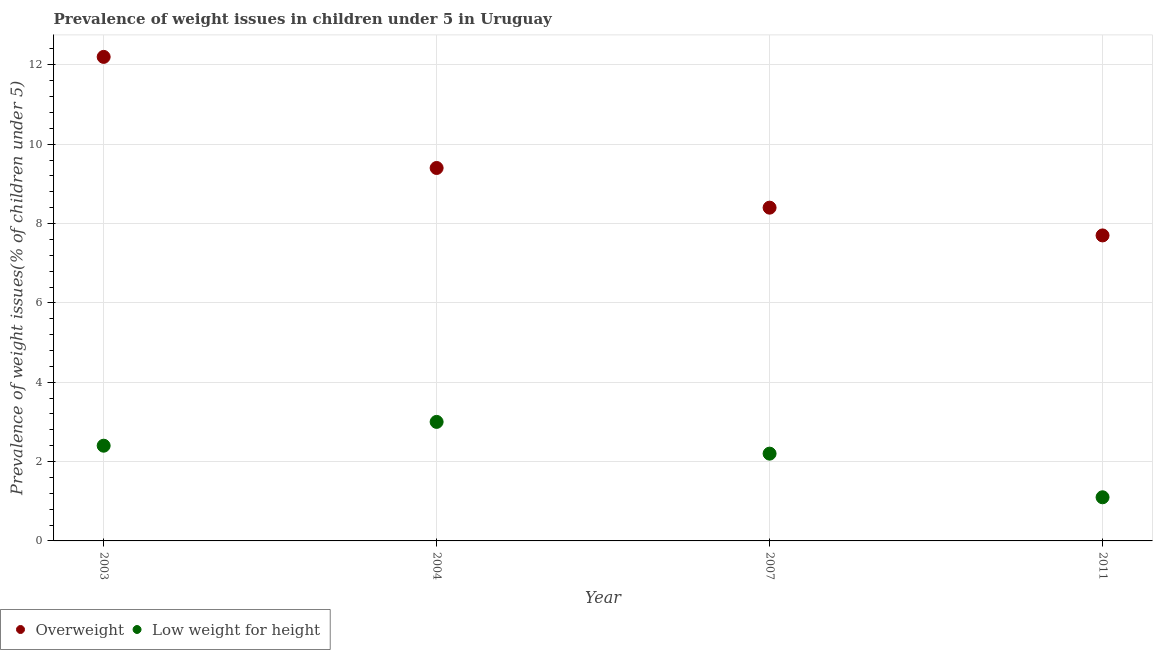How many different coloured dotlines are there?
Your answer should be compact. 2. What is the percentage of overweight children in 2003?
Give a very brief answer. 12.2. Across all years, what is the maximum percentage of overweight children?
Keep it short and to the point. 12.2. Across all years, what is the minimum percentage of overweight children?
Offer a very short reply. 7.7. In which year was the percentage of overweight children maximum?
Keep it short and to the point. 2003. What is the total percentage of overweight children in the graph?
Your response must be concise. 37.7. What is the difference between the percentage of underweight children in 2003 and that in 2007?
Your answer should be very brief. 0.2. What is the difference between the percentage of underweight children in 2011 and the percentage of overweight children in 2003?
Provide a succinct answer. -11.1. What is the average percentage of overweight children per year?
Your answer should be compact. 9.42. In the year 2011, what is the difference between the percentage of underweight children and percentage of overweight children?
Offer a very short reply. -6.6. In how many years, is the percentage of underweight children greater than 4.4 %?
Make the answer very short. 0. What is the ratio of the percentage of overweight children in 2003 to that in 2004?
Make the answer very short. 1.3. Is the percentage of overweight children in 2003 less than that in 2007?
Ensure brevity in your answer.  No. Is the difference between the percentage of underweight children in 2004 and 2011 greater than the difference between the percentage of overweight children in 2004 and 2011?
Keep it short and to the point. Yes. What is the difference between the highest and the second highest percentage of overweight children?
Your answer should be very brief. 2.8. What is the difference between the highest and the lowest percentage of overweight children?
Make the answer very short. 4.5. In how many years, is the percentage of underweight children greater than the average percentage of underweight children taken over all years?
Give a very brief answer. 3. How many years are there in the graph?
Keep it short and to the point. 4. Are the values on the major ticks of Y-axis written in scientific E-notation?
Your answer should be very brief. No. Does the graph contain any zero values?
Give a very brief answer. No. Does the graph contain grids?
Your answer should be very brief. Yes. How are the legend labels stacked?
Provide a short and direct response. Horizontal. What is the title of the graph?
Ensure brevity in your answer.  Prevalence of weight issues in children under 5 in Uruguay. Does "Researchers" appear as one of the legend labels in the graph?
Your answer should be very brief. No. What is the label or title of the X-axis?
Offer a terse response. Year. What is the label or title of the Y-axis?
Give a very brief answer. Prevalence of weight issues(% of children under 5). What is the Prevalence of weight issues(% of children under 5) of Overweight in 2003?
Keep it short and to the point. 12.2. What is the Prevalence of weight issues(% of children under 5) in Low weight for height in 2003?
Your answer should be very brief. 2.4. What is the Prevalence of weight issues(% of children under 5) in Overweight in 2004?
Your answer should be very brief. 9.4. What is the Prevalence of weight issues(% of children under 5) in Low weight for height in 2004?
Offer a very short reply. 3. What is the Prevalence of weight issues(% of children under 5) in Overweight in 2007?
Provide a short and direct response. 8.4. What is the Prevalence of weight issues(% of children under 5) of Low weight for height in 2007?
Give a very brief answer. 2.2. What is the Prevalence of weight issues(% of children under 5) in Overweight in 2011?
Your answer should be very brief. 7.7. What is the Prevalence of weight issues(% of children under 5) of Low weight for height in 2011?
Give a very brief answer. 1.1. Across all years, what is the maximum Prevalence of weight issues(% of children under 5) in Overweight?
Your answer should be compact. 12.2. Across all years, what is the maximum Prevalence of weight issues(% of children under 5) in Low weight for height?
Provide a short and direct response. 3. Across all years, what is the minimum Prevalence of weight issues(% of children under 5) in Overweight?
Keep it short and to the point. 7.7. Across all years, what is the minimum Prevalence of weight issues(% of children under 5) of Low weight for height?
Ensure brevity in your answer.  1.1. What is the total Prevalence of weight issues(% of children under 5) of Overweight in the graph?
Offer a terse response. 37.7. What is the total Prevalence of weight issues(% of children under 5) of Low weight for height in the graph?
Offer a very short reply. 8.7. What is the difference between the Prevalence of weight issues(% of children under 5) in Low weight for height in 2004 and that in 2007?
Offer a terse response. 0.8. What is the difference between the Prevalence of weight issues(% of children under 5) of Overweight in 2004 and that in 2011?
Make the answer very short. 1.7. What is the difference between the Prevalence of weight issues(% of children under 5) in Low weight for height in 2004 and that in 2011?
Your response must be concise. 1.9. What is the difference between the Prevalence of weight issues(% of children under 5) of Overweight in 2007 and that in 2011?
Provide a short and direct response. 0.7. What is the difference between the Prevalence of weight issues(% of children under 5) in Overweight in 2003 and the Prevalence of weight issues(% of children under 5) in Low weight for height in 2011?
Your answer should be very brief. 11.1. What is the difference between the Prevalence of weight issues(% of children under 5) of Overweight in 2004 and the Prevalence of weight issues(% of children under 5) of Low weight for height in 2007?
Offer a terse response. 7.2. What is the average Prevalence of weight issues(% of children under 5) in Overweight per year?
Offer a very short reply. 9.43. What is the average Prevalence of weight issues(% of children under 5) of Low weight for height per year?
Ensure brevity in your answer.  2.17. In the year 2003, what is the difference between the Prevalence of weight issues(% of children under 5) of Overweight and Prevalence of weight issues(% of children under 5) of Low weight for height?
Offer a terse response. 9.8. In the year 2007, what is the difference between the Prevalence of weight issues(% of children under 5) of Overweight and Prevalence of weight issues(% of children under 5) of Low weight for height?
Offer a terse response. 6.2. In the year 2011, what is the difference between the Prevalence of weight issues(% of children under 5) of Overweight and Prevalence of weight issues(% of children under 5) of Low weight for height?
Your answer should be compact. 6.6. What is the ratio of the Prevalence of weight issues(% of children under 5) of Overweight in 2003 to that in 2004?
Your answer should be very brief. 1.3. What is the ratio of the Prevalence of weight issues(% of children under 5) in Low weight for height in 2003 to that in 2004?
Give a very brief answer. 0.8. What is the ratio of the Prevalence of weight issues(% of children under 5) of Overweight in 2003 to that in 2007?
Your answer should be very brief. 1.45. What is the ratio of the Prevalence of weight issues(% of children under 5) of Overweight in 2003 to that in 2011?
Offer a very short reply. 1.58. What is the ratio of the Prevalence of weight issues(% of children under 5) of Low weight for height in 2003 to that in 2011?
Offer a very short reply. 2.18. What is the ratio of the Prevalence of weight issues(% of children under 5) in Overweight in 2004 to that in 2007?
Keep it short and to the point. 1.12. What is the ratio of the Prevalence of weight issues(% of children under 5) in Low weight for height in 2004 to that in 2007?
Provide a succinct answer. 1.36. What is the ratio of the Prevalence of weight issues(% of children under 5) of Overweight in 2004 to that in 2011?
Give a very brief answer. 1.22. What is the ratio of the Prevalence of weight issues(% of children under 5) of Low weight for height in 2004 to that in 2011?
Your answer should be compact. 2.73. What is the ratio of the Prevalence of weight issues(% of children under 5) in Overweight in 2007 to that in 2011?
Your answer should be very brief. 1.09. What is the ratio of the Prevalence of weight issues(% of children under 5) in Low weight for height in 2007 to that in 2011?
Your answer should be compact. 2. What is the difference between the highest and the lowest Prevalence of weight issues(% of children under 5) in Low weight for height?
Your response must be concise. 1.9. 